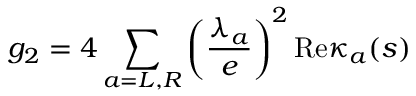Convert formula to latex. <formula><loc_0><loc_0><loc_500><loc_500>g _ { 2 } = 4 \sum _ { a = L , R } \left ( \frac { \lambda _ { a } } { e } \right ) ^ { 2 } R e \kappa _ { a } ( s )</formula> 